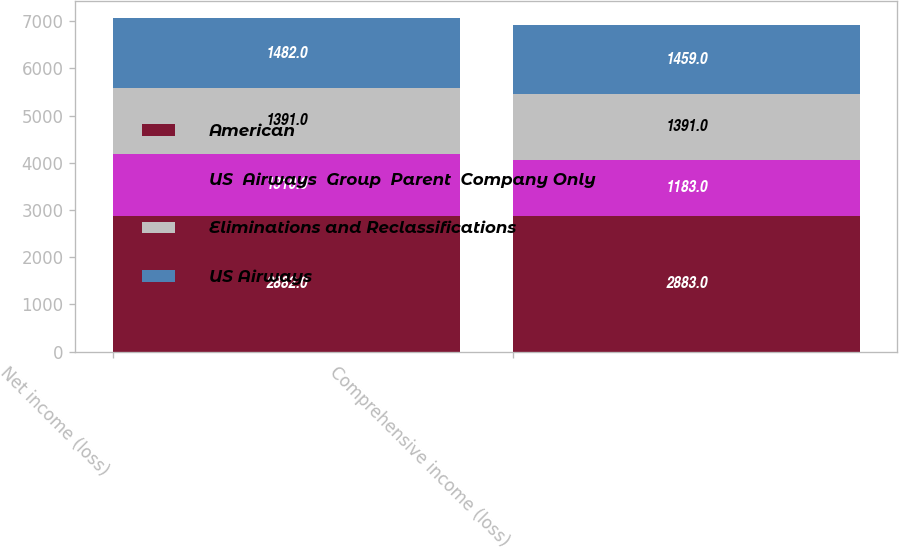Convert chart to OTSL. <chart><loc_0><loc_0><loc_500><loc_500><stacked_bar_chart><ecel><fcel>Net income (loss)<fcel>Comprehensive income (loss)<nl><fcel>American<fcel>2882<fcel>2883<nl><fcel>US  Airways  Group  Parent  Company Only<fcel>1310<fcel>1183<nl><fcel>Eliminations and Reclassifications<fcel>1391<fcel>1391<nl><fcel>US Airways<fcel>1482<fcel>1459<nl></chart> 